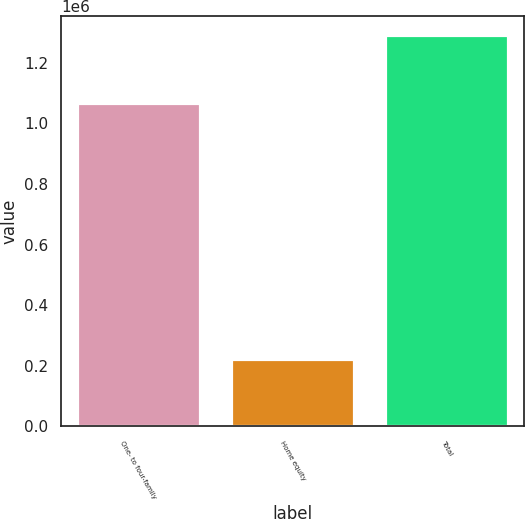<chart> <loc_0><loc_0><loc_500><loc_500><bar_chart><fcel>One- to four-family<fcel>Home equity<fcel>Total<nl><fcel>1.06617e+06<fcel>223419<fcel>1.28959e+06<nl></chart> 